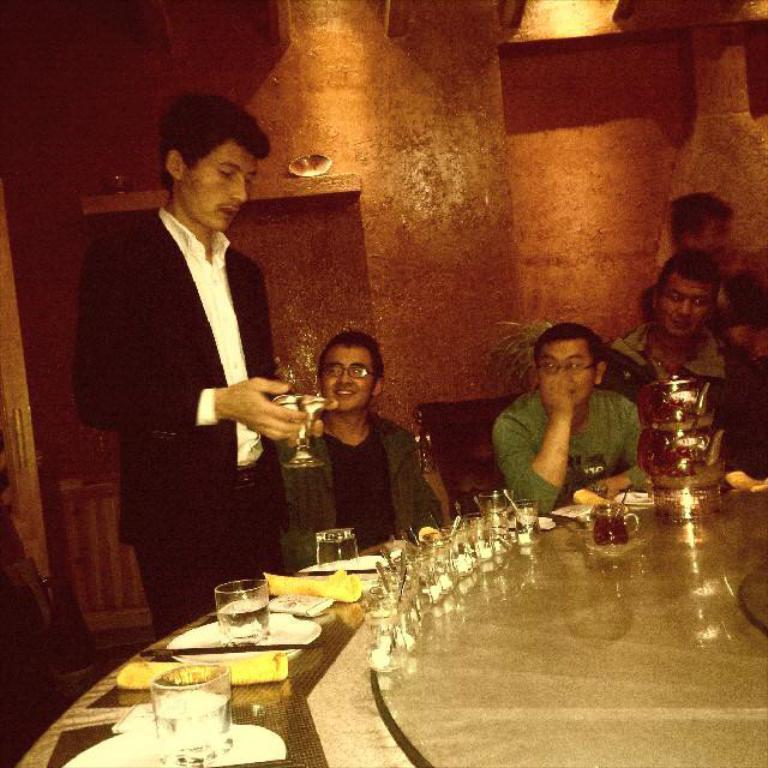Could you give a brief overview of what you see in this image? Here, there is dining table with three plates and three glasses filled with water in it. We can see the man standing catching a glass in his hand and he is wearing black color blazer. Beside him the man in green color coat is sitting on the chair and he is wearing spectacles. Beside this man, the other man in green t-shirt is sitting on a chair and watching the man standing over there. Next to him, the two mens are the two men are watching and totally there are five men, two are standing and the remaining three are sitting and watching them. Behind these men, we can see a red color wall. This dining table consists of many jars,and cups and also vessels. 